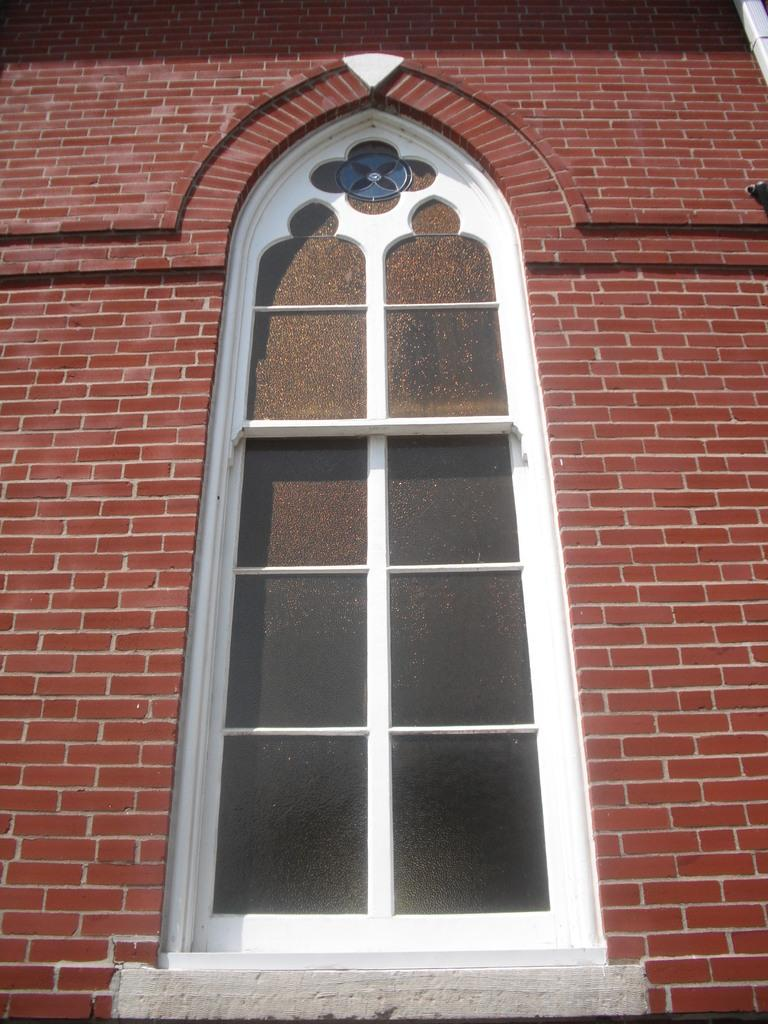What type of structure can be seen in the image? There is a wall in the image. What material is the wall made of? The wall is made up of bricks. Is there any opening in the wall? Yes, there is a window in the wall. What type of protest is happening in front of the wall in the image? There is no protest visible in the image; it only shows a wall made of bricks with a window. 